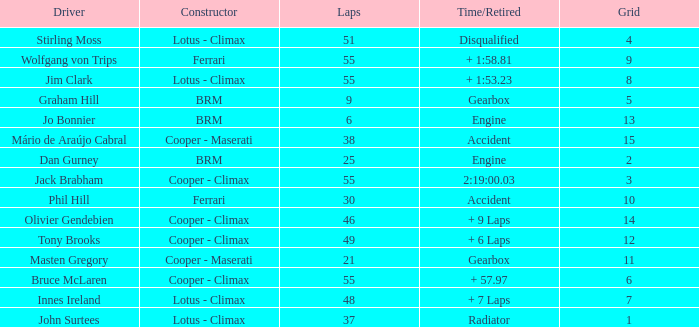Tell me the laps for 3 grids 55.0. 